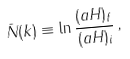<formula> <loc_0><loc_0><loc_500><loc_500>\bar { N } ( k ) \equiv \ln \frac { ( a H ) _ { f } } { ( a H ) _ { i } } \, ,</formula> 